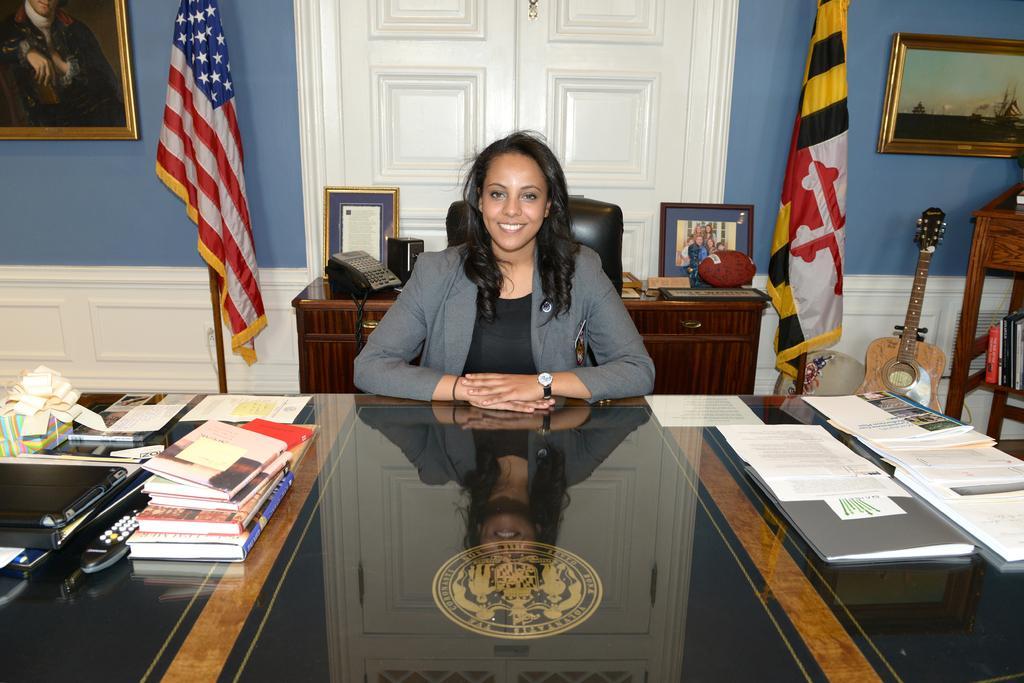In one or two sentences, can you explain what this image depicts? Here in this picture we can see a woman wearing a coat and sitting on a chair and smiling and in front of her we can see a table, on which we can see number of papers and books and a remote present and behind her we can see a table with drawers and cup boards present and on that we can see a telephone and some photo frames present and beside her on either side we can see flag posts present and on the walls we can see portraits present and on the right side we can see a guitar present and we can see a shelf with books present. 